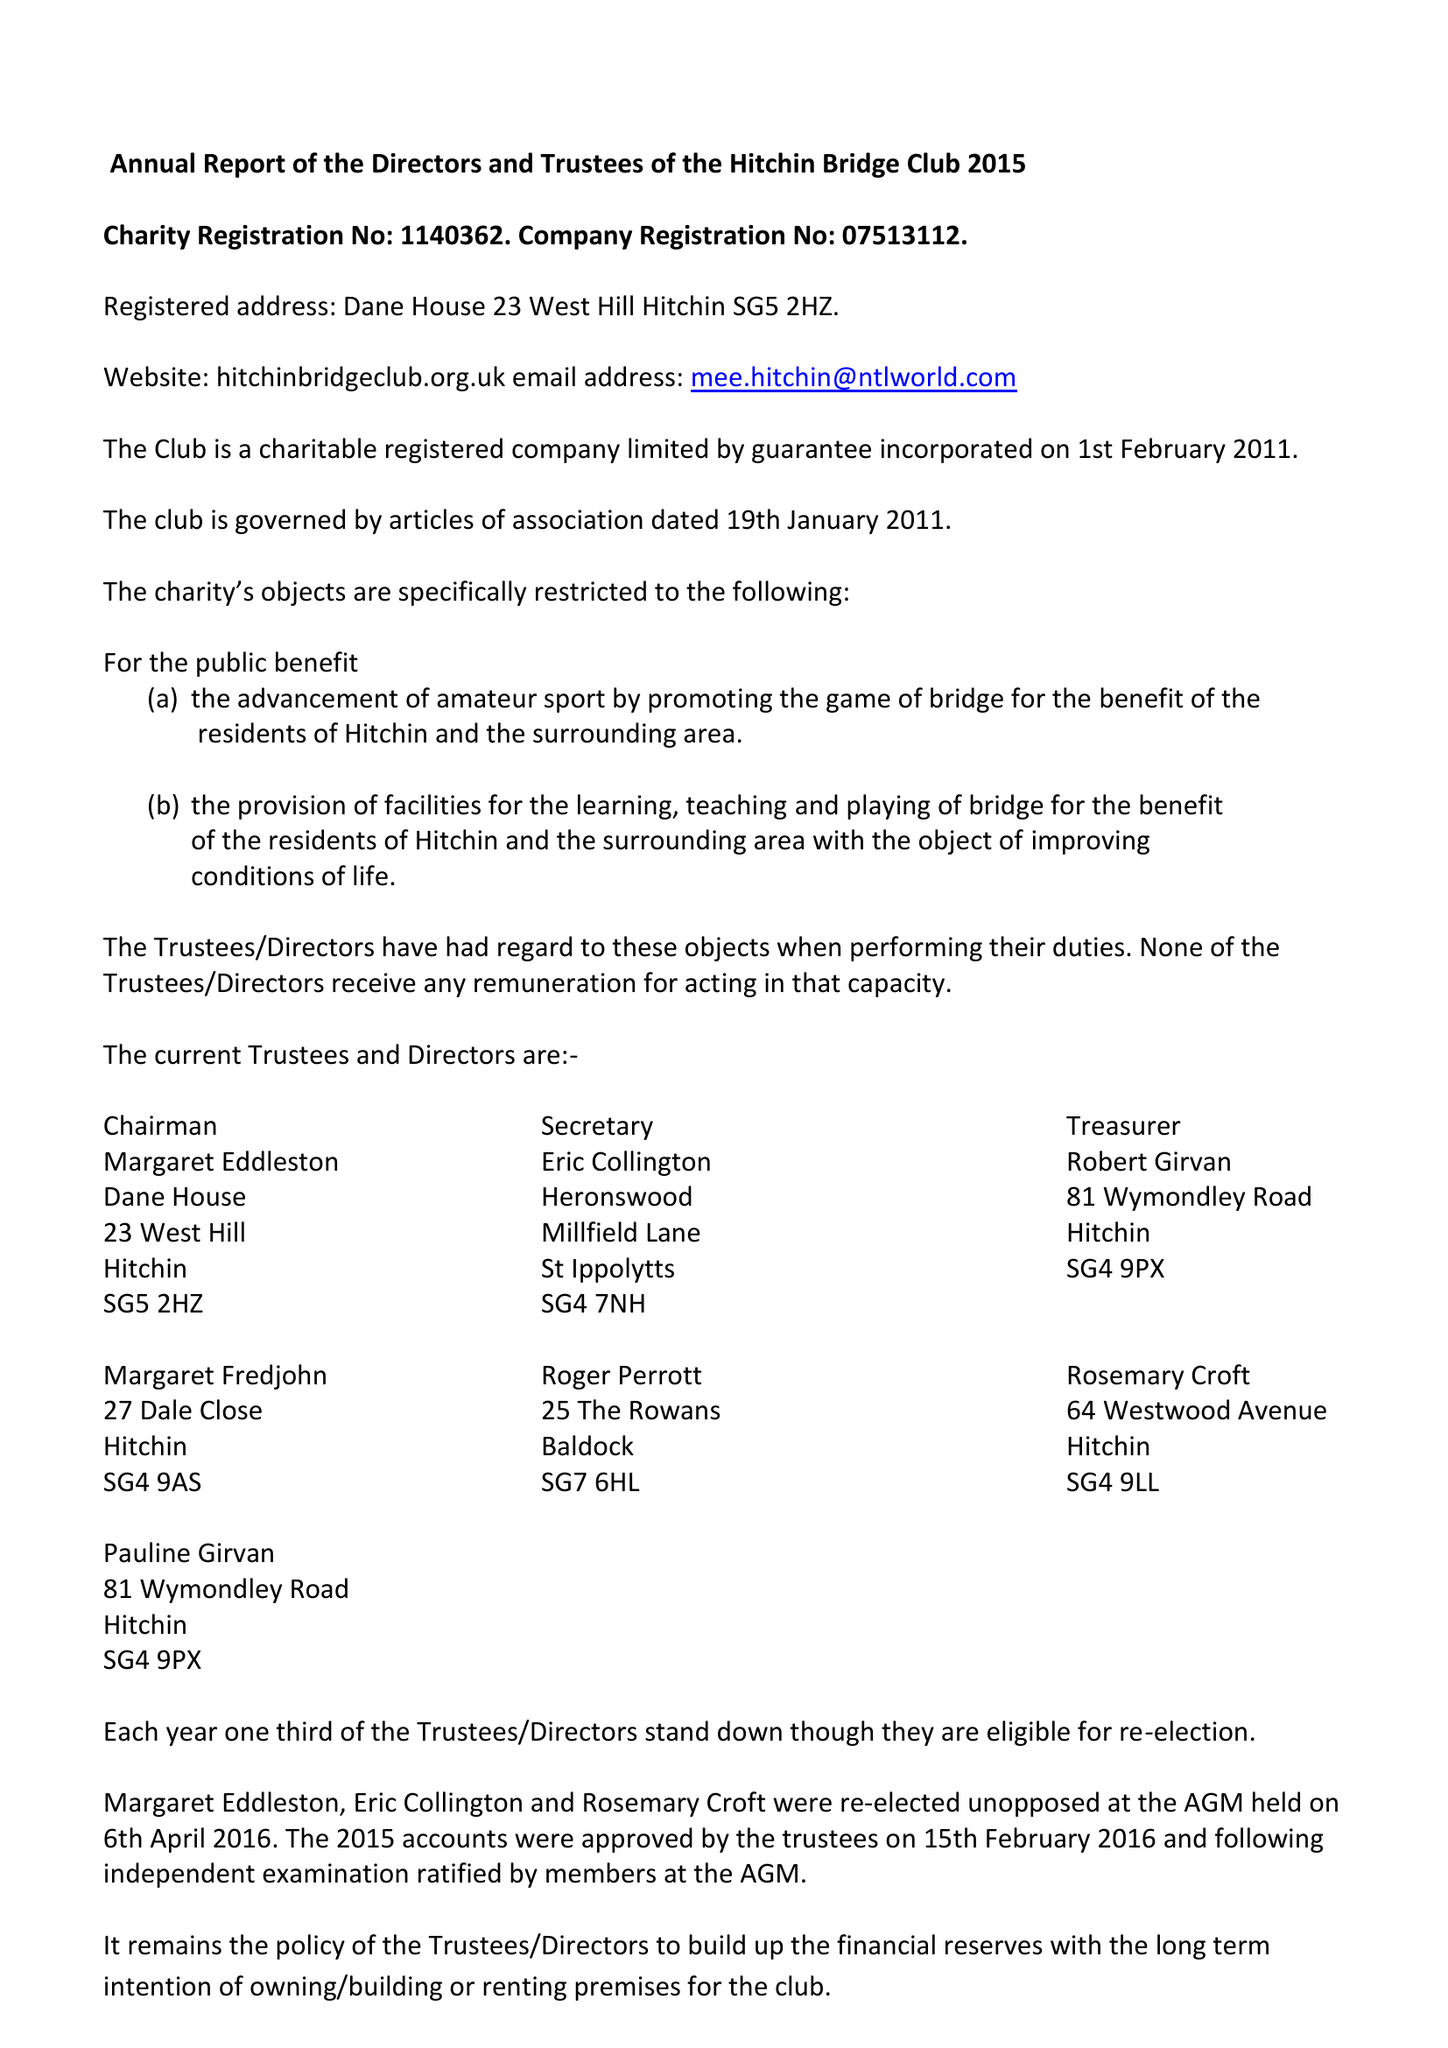What is the value for the report_date?
Answer the question using a single word or phrase. 2015-12-31 